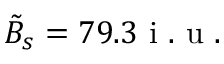<formula> <loc_0><loc_0><loc_500><loc_500>\tilde { B } _ { s } = 7 9 . 3 i . u .</formula> 